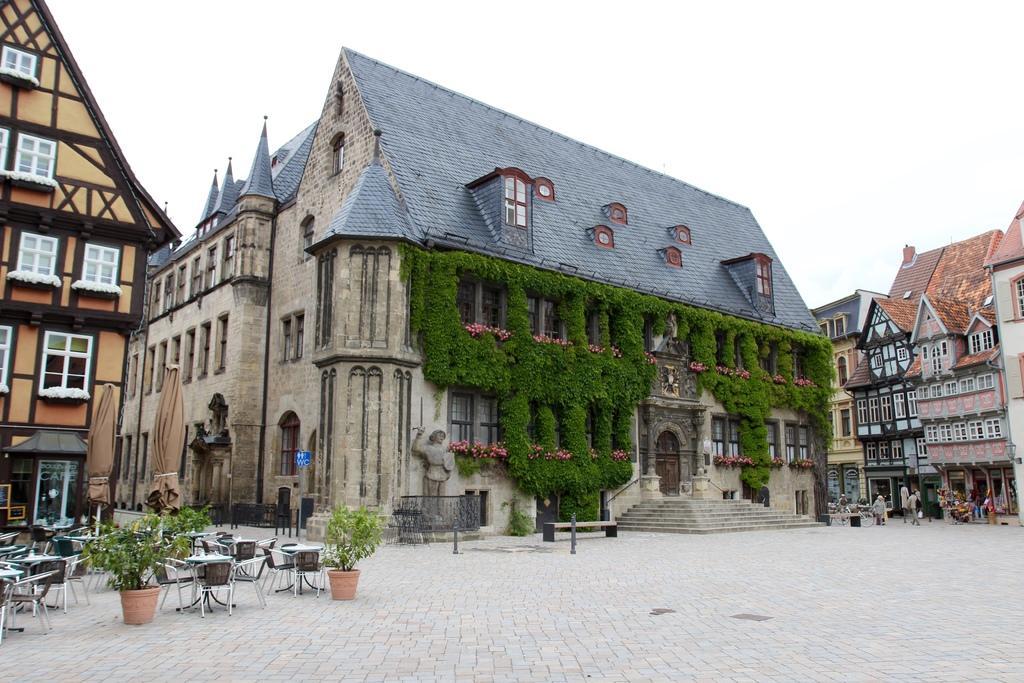Can you describe this image briefly? To the left side of the image there are tables, chairs and pots with plants. And also there is a building with brown color wall and white color window. And in the middle of the image there is a house with roofs, sculptures, walls, windows, in front of the door there are steps. On the building walls there are creepers. To the right corner of the image there are buildings with roofs, windows and walls. In front of the building there are few people standing. And to the top of the image there is a sky. 